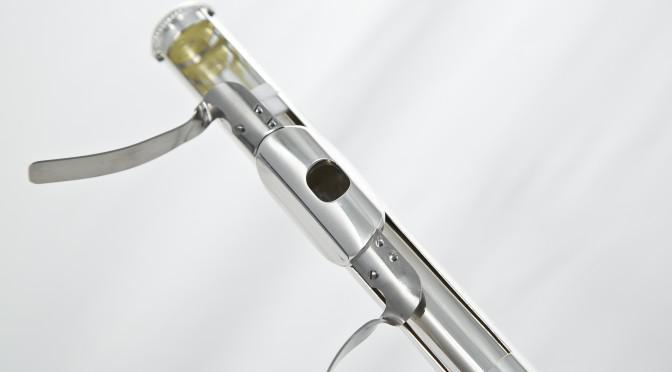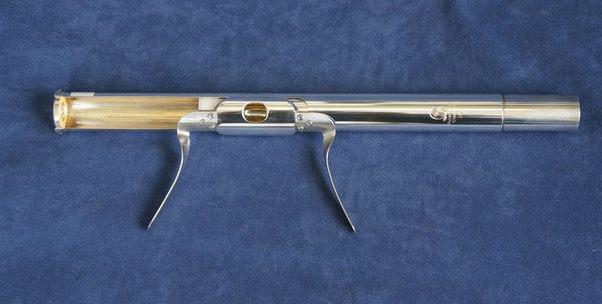The first image is the image on the left, the second image is the image on the right. Analyze the images presented: Is the assertion "The right image contains a single instrument." valid? Answer yes or no. Yes. 